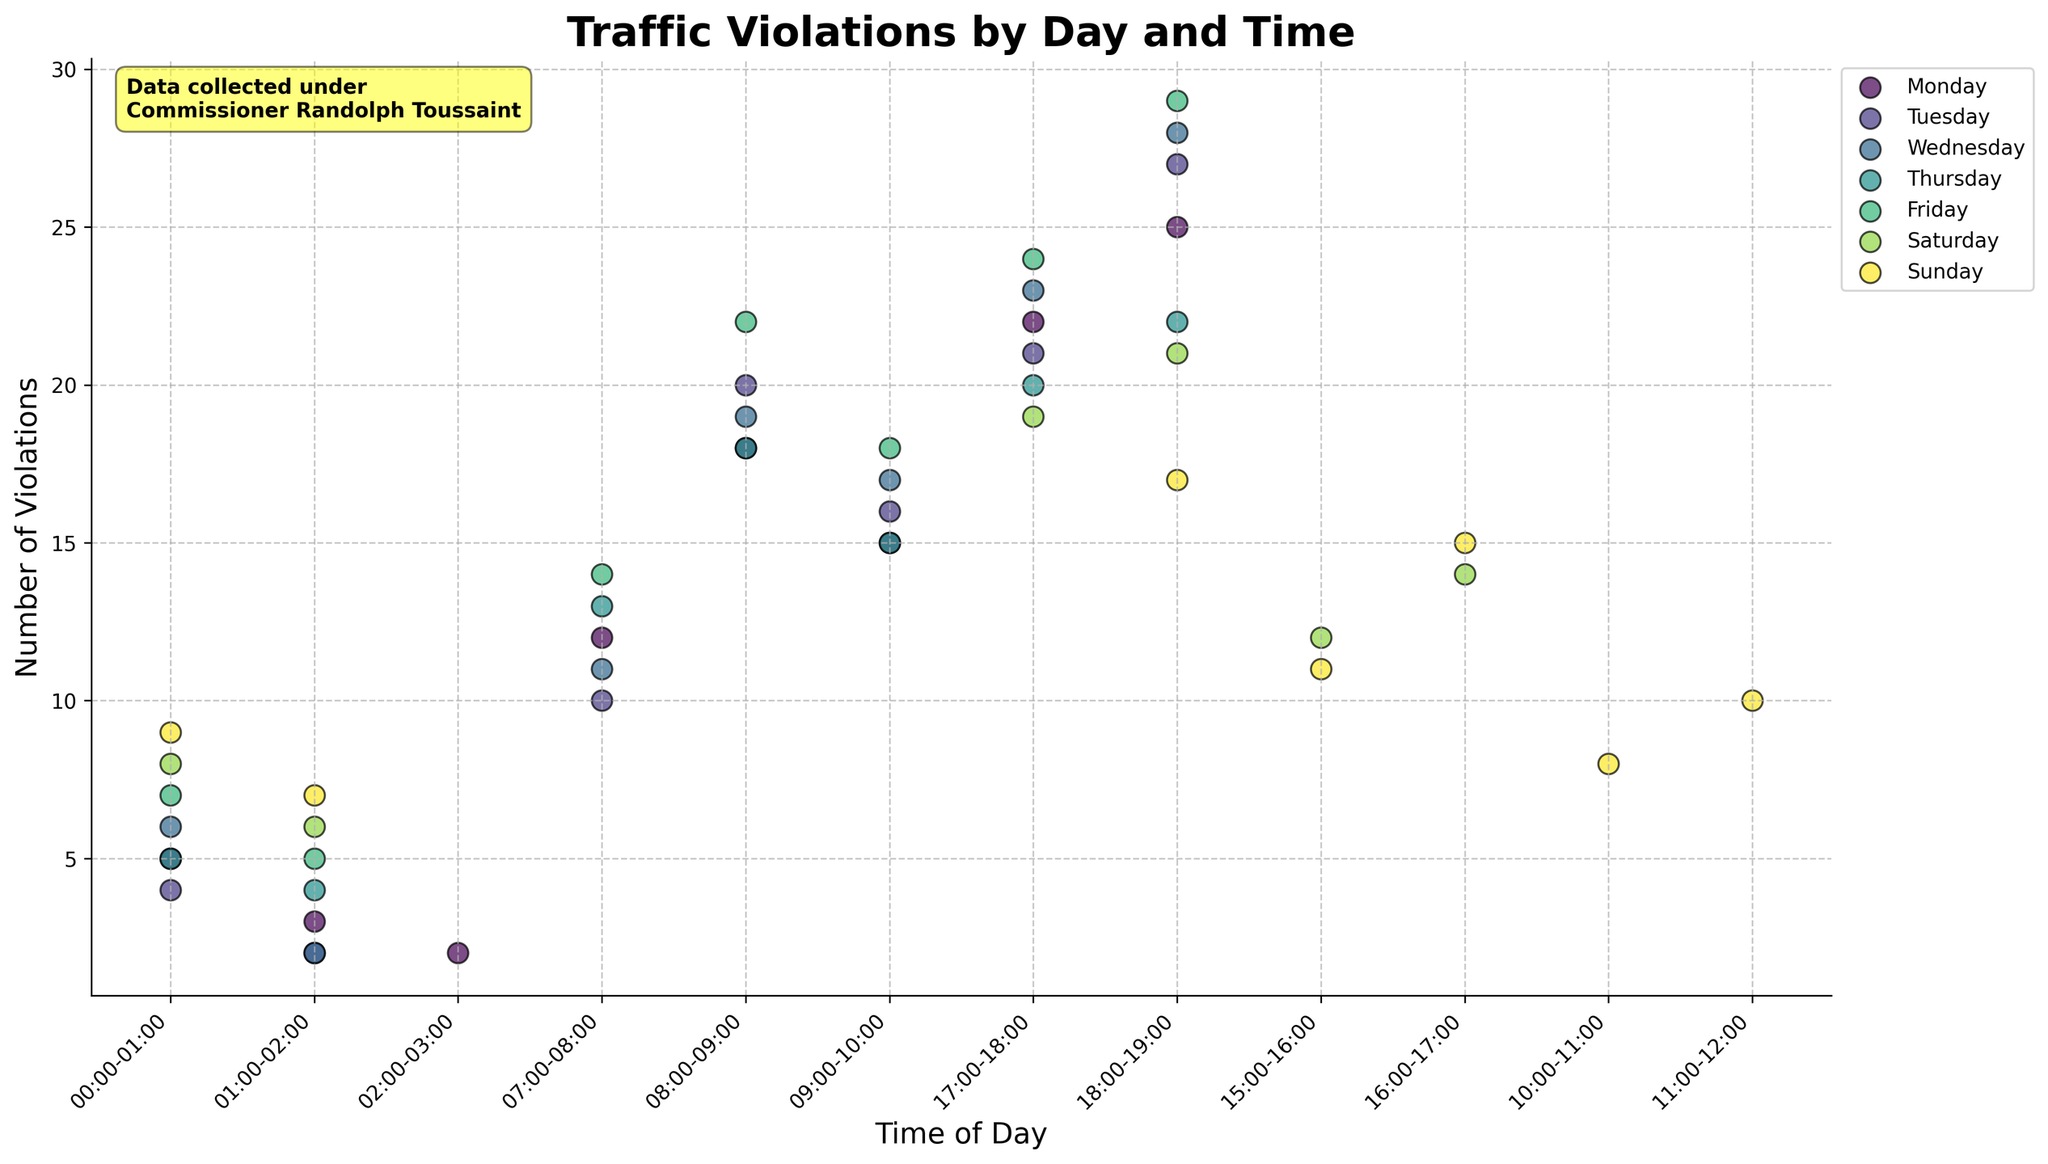How many traffic violations were recorded on Monday from 18:00-19:00? Look at the data points for Monday and locate the one for 18:00-19:00. It shows 25 violations.
Answer: 25 Which day had the highest recorded traffic violations in the 18:00-19:00 time slot? Check each day for violations in the 18:00-19:00 time slot. Wednesday has 28 violations, which is the highest.
Answer: Wednesday Is there any day where the number of violations is consistently increasing throughout the day? Compare the violation counts across time slots for each day to see if any day shows a consistent increase. There is no day with a continuously increasing trend.
Answer: No What time periods are most likely to see an increase in traffic violations across the week? Reviewing the data, the 17:00-19:00 time period has the highest violations for multiple days like Monday, Tuesday, Wednesday, Friday, and Saturday.
Answer: 17:00-19:00 Which time slot on Saturday has the highest traffic violations? Check all time slots for Saturday. The 18:00-19:00 slot with 21 violations is the highest.
Answer: 18:00-19:00 During which day and time slot is there the lowest number of traffic violations? Find the minimum value by comparing all days and their respective time slots. The lowest is 2 violations during Monday 02:00-03:00, Tuesday 01:00-02:00, and Wednesday 01:00-02:00.
Answer: Monday 02:00-03:00, Tuesday 01:00-02:00, Wednesday 01:00-02:00 Compare the number of violations between 08:00-09:00 and 17:00-18:00 on Friday. Which one is higher? For Friday, check violations for 08:00-09:00 (22) and 17:00-18:00 (24). 24 is greater than 22.
Answer: 17:00-18:00 What is the common visual feature used to differentiate data for each day in the plot? Each day is represented by different colors as indicated by the legend.
Answer: Different colors How does the trend of traffic violations on weekdays between 07:00-10:00 compare to the same period during the weekend? Review weekday values (07:00-10:00) for violations ranging from 10 to 22, which are higher compared to weekend morning values of 8.
Answer: Weekdays are higher Does the plot contain any additional annotations or information related to Commissioner Randolph Toussaint? Yes, there is an annotation mentioning that the data was collected under Commissioner Randolph Toussaint.
Answer: Yes 